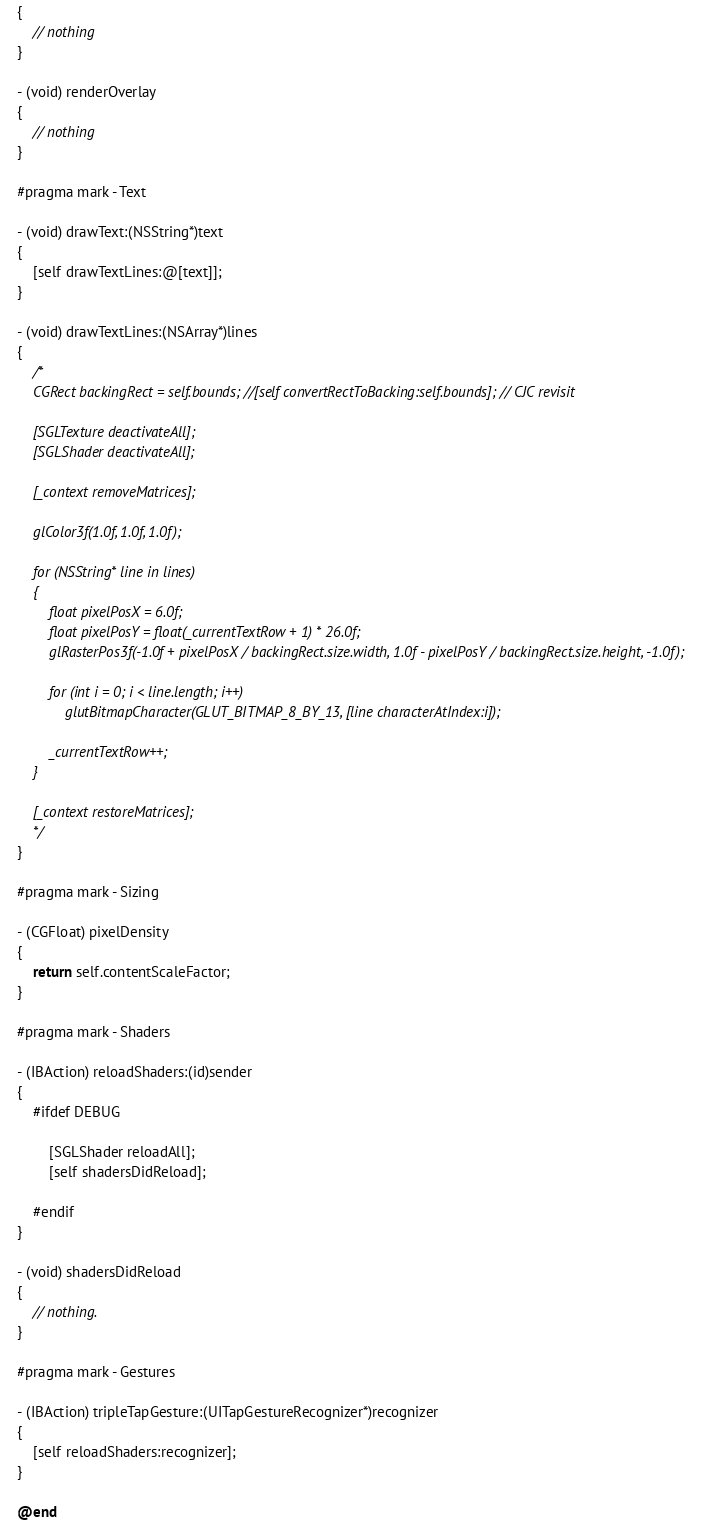<code> <loc_0><loc_0><loc_500><loc_500><_ObjectiveC_>{
    // nothing
}

- (void) renderOverlay
{
    // nothing
}

#pragma mark - Text

- (void) drawText:(NSString*)text
{
    [self drawTextLines:@[text]];
}

- (void) drawTextLines:(NSArray*)lines
{
    /*
    CGRect backingRect = self.bounds; //[self convertRectToBacking:self.bounds]; // CJC revisit
    
    [SGLTexture deactivateAll];
    [SGLShader deactivateAll];
    
    [_context removeMatrices];
    
    glColor3f(1.0f, 1.0f, 1.0f);
    
    for (NSString* line in lines)
    {
        float pixelPosX = 6.0f;
        float pixelPosY = float(_currentTextRow + 1) * 26.0f;
        glRasterPos3f(-1.0f + pixelPosX / backingRect.size.width, 1.0f - pixelPosY / backingRect.size.height, -1.0f);
        
        for (int i = 0; i < line.length; i++)
            glutBitmapCharacter(GLUT_BITMAP_8_BY_13, [line characterAtIndex:i]);
        
        _currentTextRow++;
    }
    
    [_context restoreMatrices];
    */
}

#pragma mark - Sizing

- (CGFloat) pixelDensity
{
    return self.contentScaleFactor;
}

#pragma mark - Shaders

- (IBAction) reloadShaders:(id)sender
{
    #ifdef DEBUG
    
        [SGLShader reloadAll];
        [self shadersDidReload];
        
    #endif
}

- (void) shadersDidReload
{
    // nothing.
}

#pragma mark - Gestures

- (IBAction) tripleTapGesture:(UITapGestureRecognizer*)recognizer
{
    [self reloadShaders:recognizer];
}

@end
</code> 